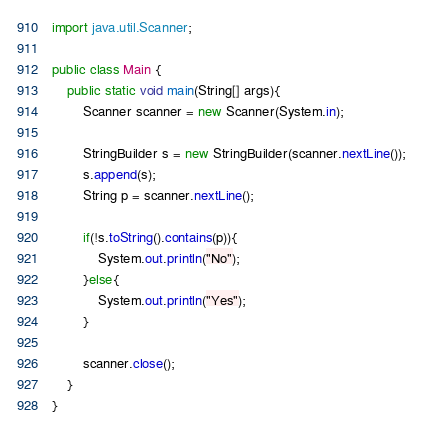Convert code to text. <code><loc_0><loc_0><loc_500><loc_500><_Java_>import java.util.Scanner;

public class Main {
    public static void main(String[] args){
        Scanner scanner = new Scanner(System.in);

        StringBuilder s = new StringBuilder(scanner.nextLine());
        s.append(s);
        String p = scanner.nextLine();

        if(!s.toString().contains(p)){
            System.out.println("No");
        }else{
            System.out.println("Yes");
        }

        scanner.close();
    }
}

</code> 